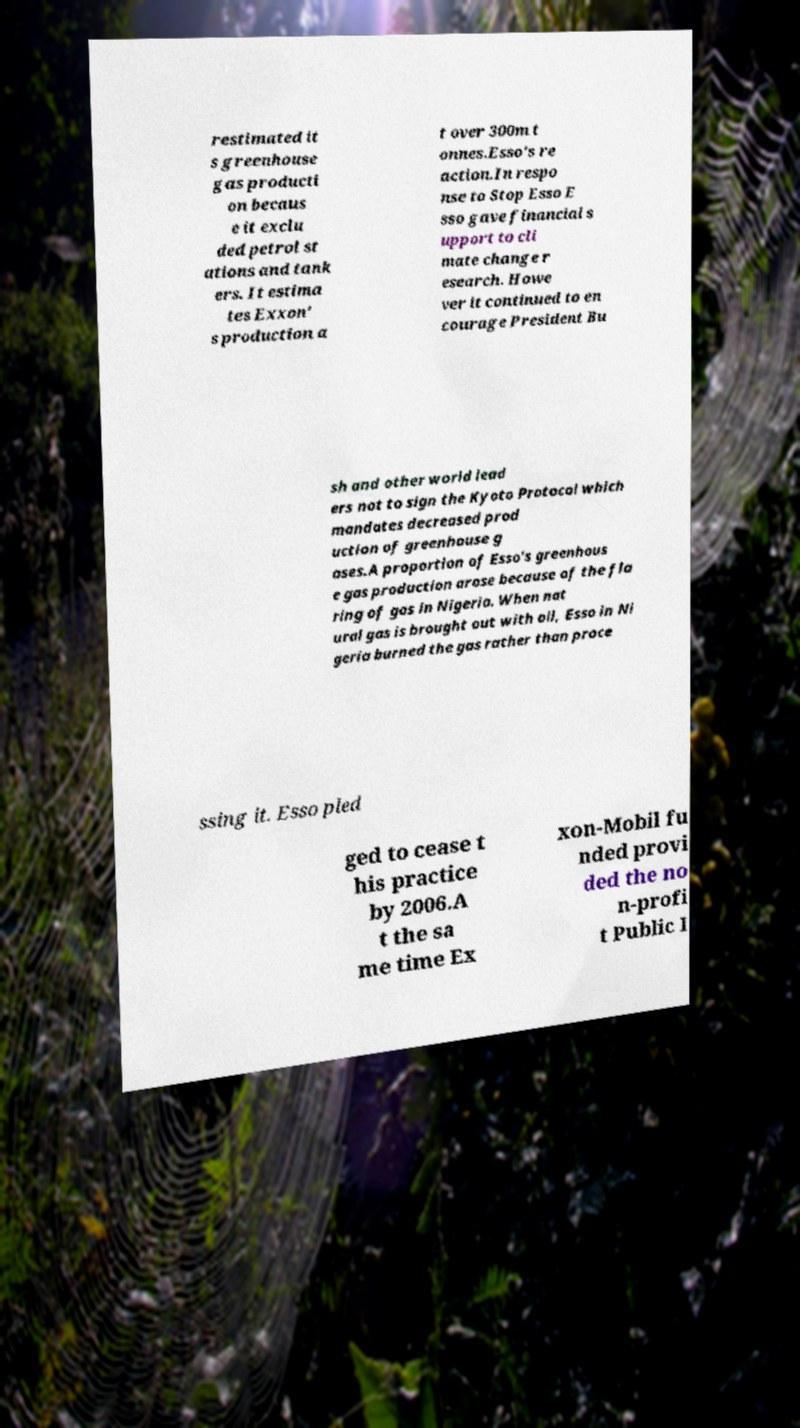I need the written content from this picture converted into text. Can you do that? restimated it s greenhouse gas producti on becaus e it exclu ded petrol st ations and tank ers. It estima tes Exxon' s production a t over 300m t onnes.Esso's re action.In respo nse to Stop Esso E sso gave financial s upport to cli mate change r esearch. Howe ver it continued to en courage President Bu sh and other world lead ers not to sign the Kyoto Protocol which mandates decreased prod uction of greenhouse g ases.A proportion of Esso's greenhous e gas production arose because of the fla ring of gas in Nigeria. When nat ural gas is brought out with oil, Esso in Ni geria burned the gas rather than proce ssing it. Esso pled ged to cease t his practice by 2006.A t the sa me time Ex xon-Mobil fu nded provi ded the no n-profi t Public I 